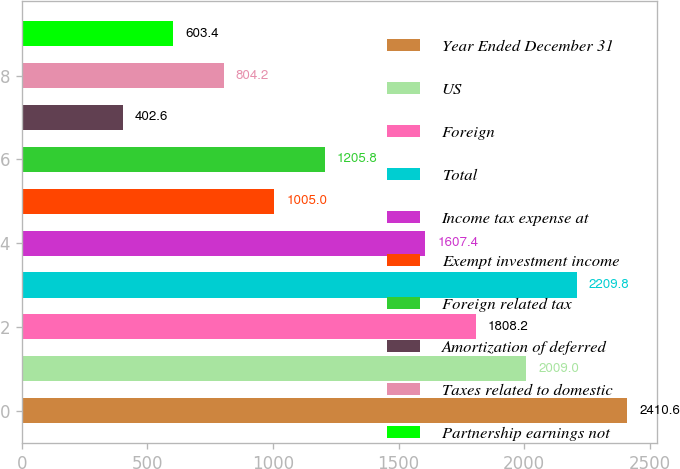Convert chart to OTSL. <chart><loc_0><loc_0><loc_500><loc_500><bar_chart><fcel>Year Ended December 31<fcel>US<fcel>Foreign<fcel>Total<fcel>Income tax expense at<fcel>Exempt investment income<fcel>Foreign related tax<fcel>Amortization of deferred<fcel>Taxes related to domestic<fcel>Partnership earnings not<nl><fcel>2410.6<fcel>2009<fcel>1808.2<fcel>2209.8<fcel>1607.4<fcel>1005<fcel>1205.8<fcel>402.6<fcel>804.2<fcel>603.4<nl></chart> 